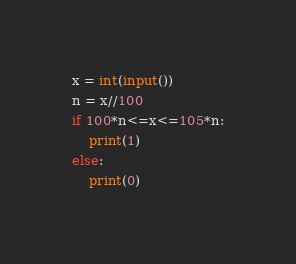Convert code to text. <code><loc_0><loc_0><loc_500><loc_500><_Python_>x = int(input())
n = x//100
if 100*n<=x<=105*n:
    print(1)
else:
    print(0)</code> 